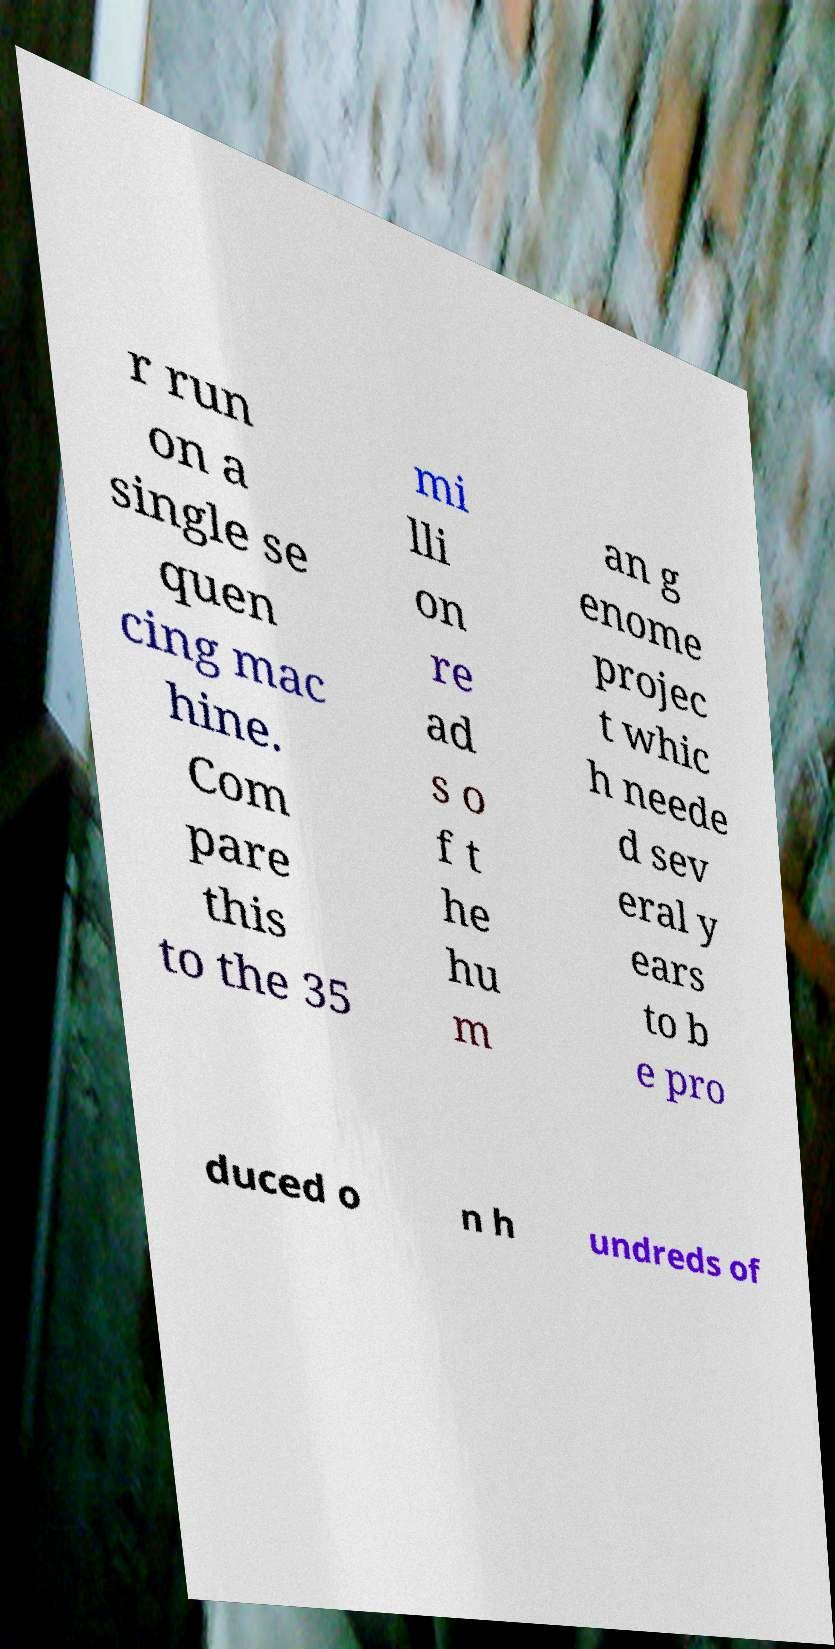Please read and relay the text visible in this image. What does it say? r run on a single se quen cing mac hine. Com pare this to the 35 mi lli on re ad s o f t he hu m an g enome projec t whic h neede d sev eral y ears to b e pro duced o n h undreds of 